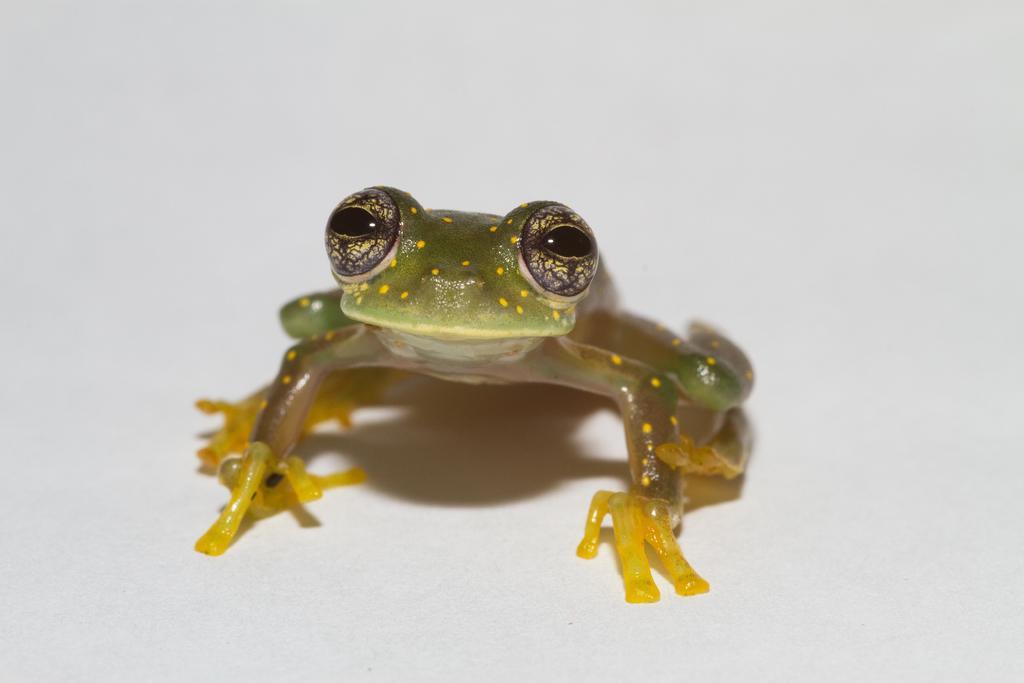Please provide a concise description of this image. In this picture we can see the frog. Background is white in color. 